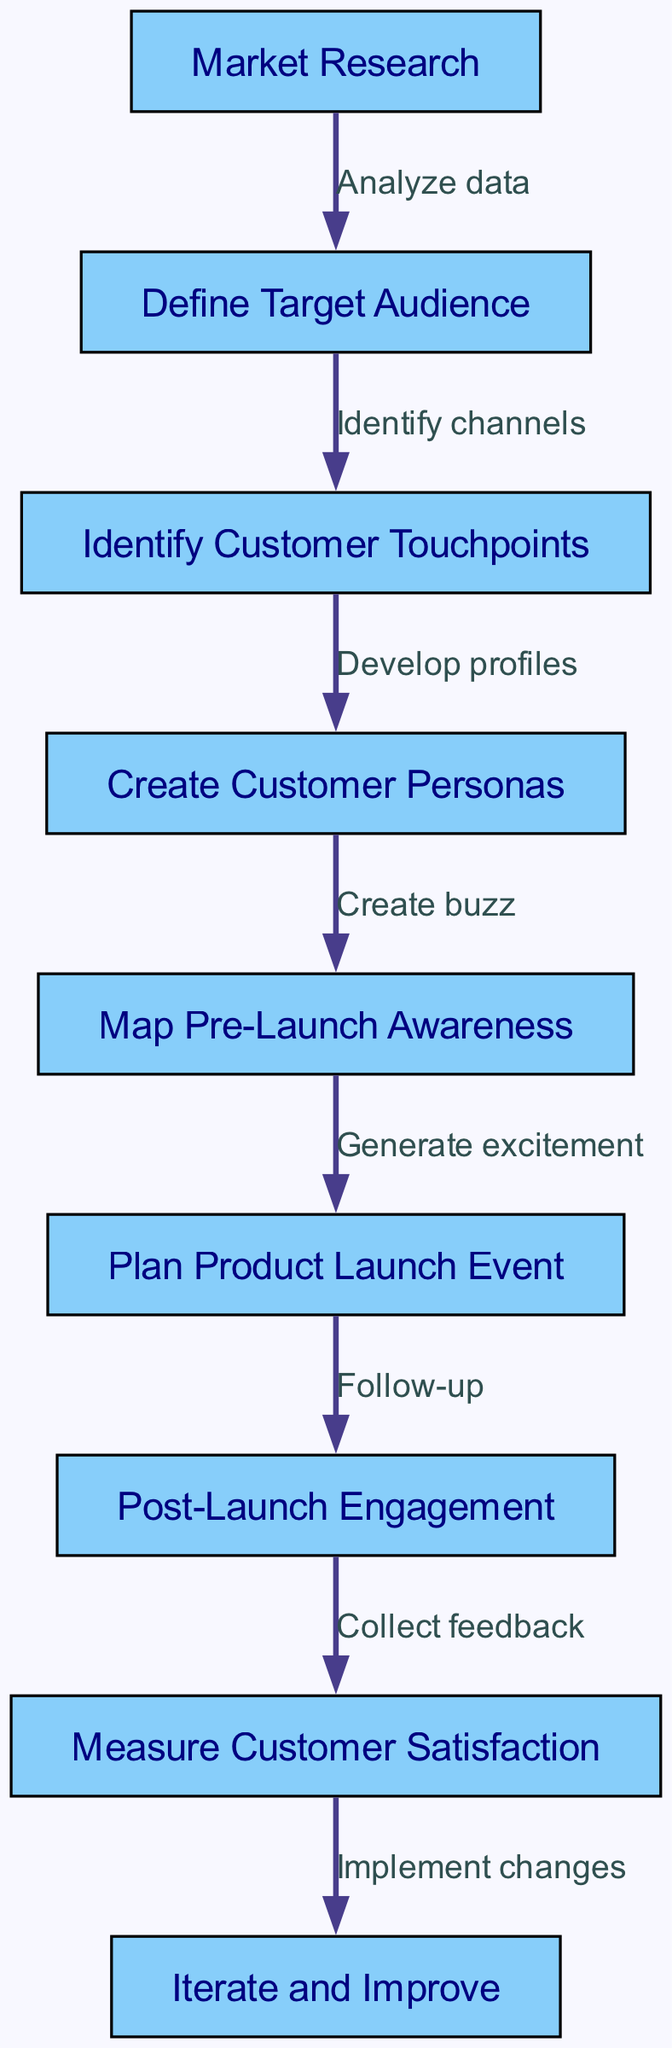What is the first step in the customer journey mapping process? The first step in the diagram, as indicated by the starting node, is "Market Research."
Answer: Market Research How many nodes are in this diagram? To find the number of nodes, we can count each unique step listed in the nodes section. There are a total of 9 nodes.
Answer: 9 What is the relationship between "Define Target Audience" and "Identify Customer Touchpoints"? The relationship is defined by the edge that indicates the transition from "Define Target Audience" to "Identify Customer Touchpoints," which states "Identify channels."
Answer: Identify channels What comes after "Map Pre-Launch Awareness"? The next step after "Map Pre-Launch Awareness" is "Plan Product Launch Event," as indicated by the directed edge leading from one to the other.
Answer: Plan Product Launch Event What is the final stage of the customer journey mapping process? The final stage, as shown in the last node in the diagram, is "Iterate and Improve."
Answer: Iterate and Improve Which node precedes the "Create Customer Personas"? The node that precedes "Create Customer Personas" is "Identify Customer Touchpoints," as indicated by the directed edge leading to it.
Answer: Identify Customer Touchpoints How many edges are in this diagram? By counting the connections between nodes from the edges section, there are a total of 8 edges.
Answer: 8 Explain the flow from "Post-Launch Engagement" to "Measure Customer Satisfaction." The flow indicates that after "Post-Launch Engagement," the next step is to "Collect feedback," which then leads to "Measure Customer Satisfaction." This means post-launch activities focus on gathering feedback before measuring satisfaction.
Answer: Collect feedback 